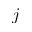<formula> <loc_0><loc_0><loc_500><loc_500>j</formula> 